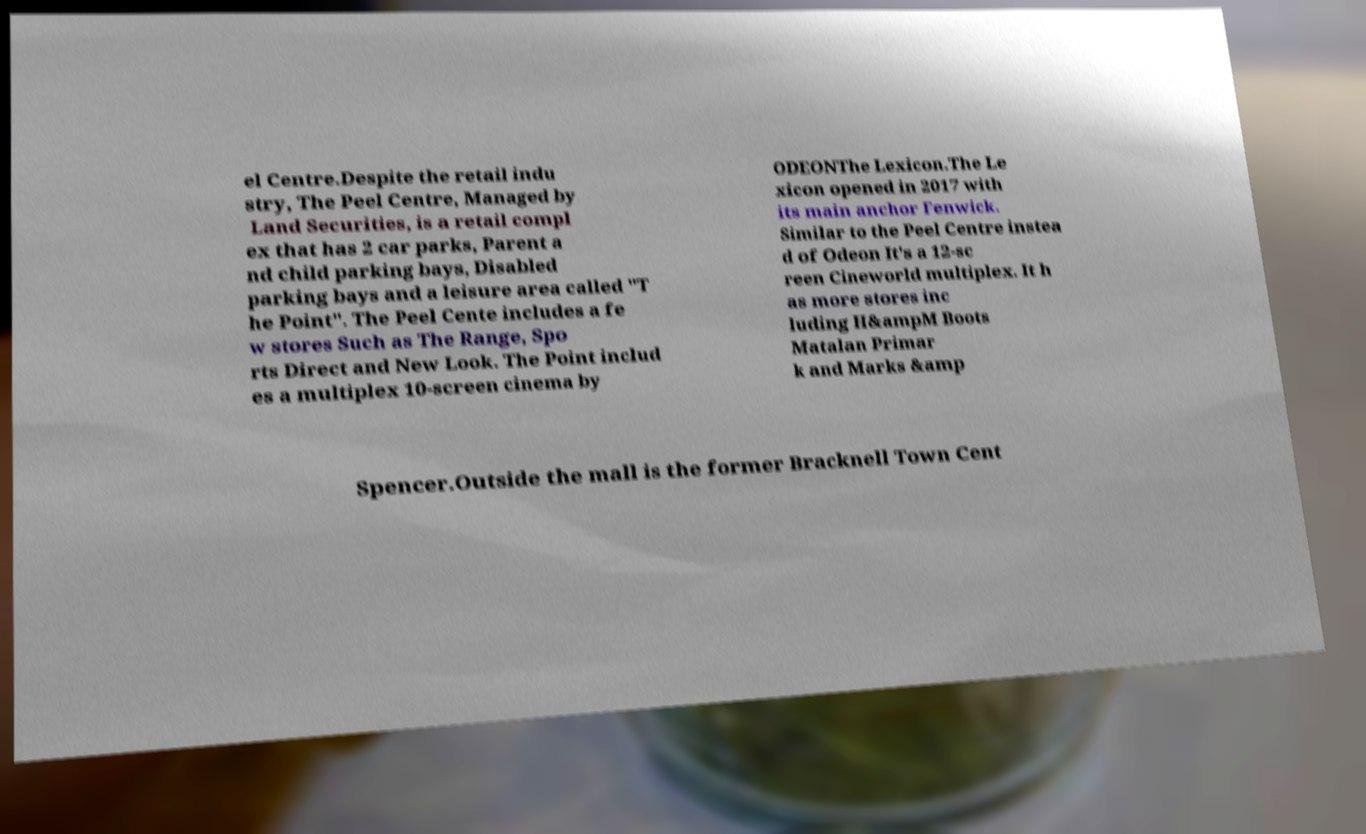Could you assist in decoding the text presented in this image and type it out clearly? el Centre.Despite the retail indu stry, The Peel Centre, Managed by Land Securities, is a retail compl ex that has 2 car parks, Parent a nd child parking bays, Disabled parking bays and a leisure area called "T he Point". The Peel Cente includes a fe w stores Such as The Range, Spo rts Direct and New Look. The Point includ es a multiplex 10-screen cinema by ODEONThe Lexicon.The Le xicon opened in 2017 with its main anchor Fenwick. Similar to the Peel Centre instea d of Odeon It's a 12-sc reen Cineworld multiplex. It h as more stores inc luding H&ampM Boots Matalan Primar k and Marks &amp Spencer.Outside the mall is the former Bracknell Town Cent 